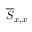<formula> <loc_0><loc_0><loc_500><loc_500>\overline { S } _ { x , x }</formula> 